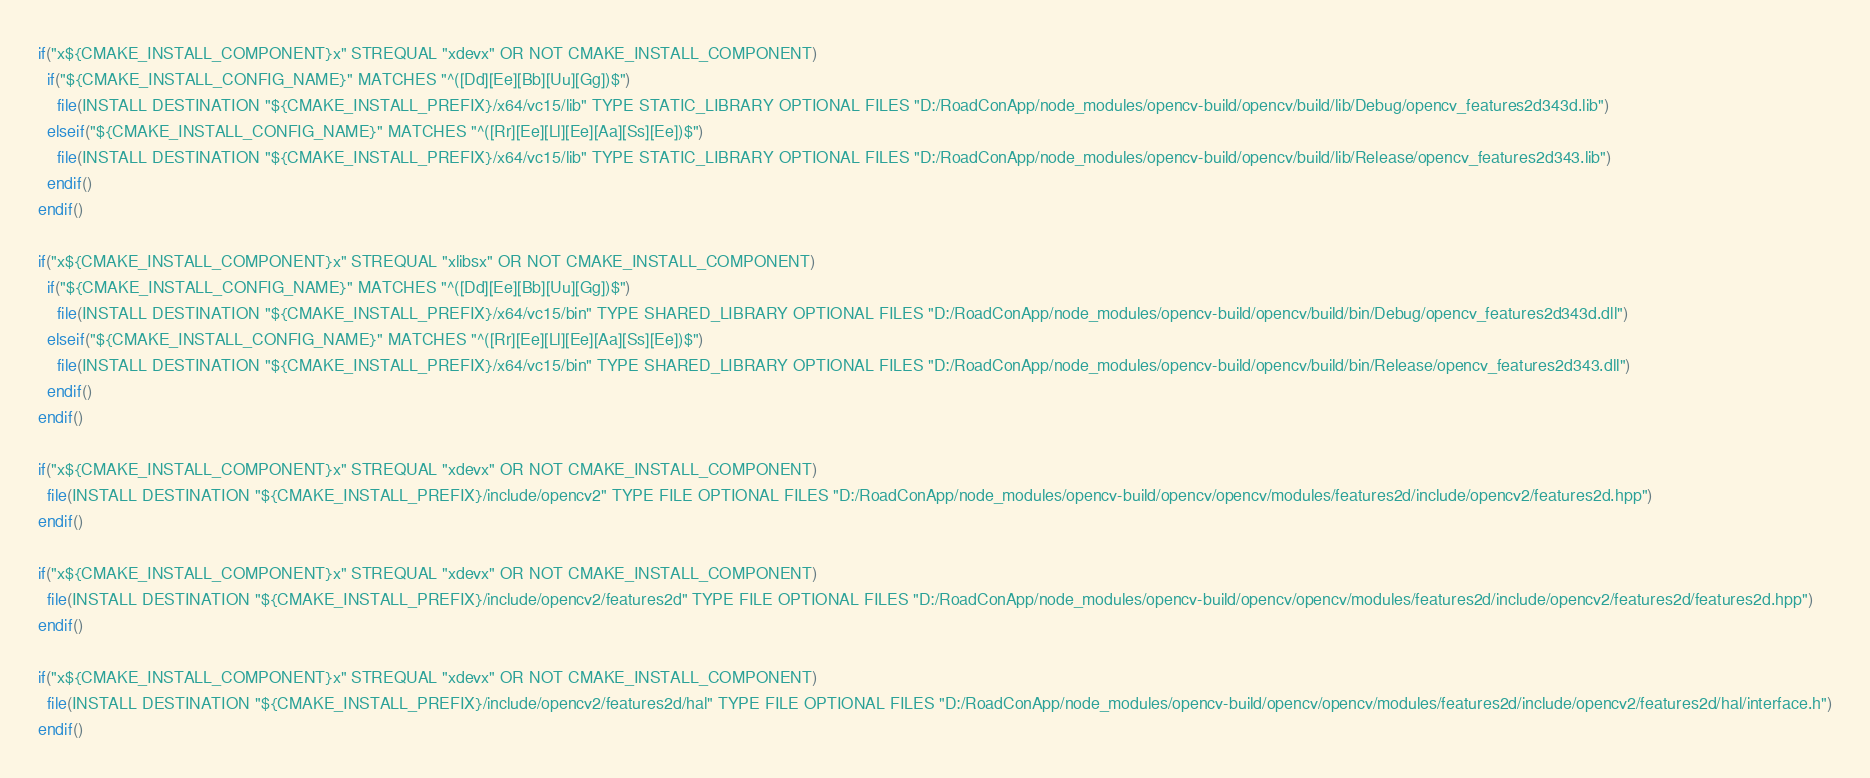Convert code to text. <code><loc_0><loc_0><loc_500><loc_500><_CMake_>if("x${CMAKE_INSTALL_COMPONENT}x" STREQUAL "xdevx" OR NOT CMAKE_INSTALL_COMPONENT)
  if("${CMAKE_INSTALL_CONFIG_NAME}" MATCHES "^([Dd][Ee][Bb][Uu][Gg])$")
    file(INSTALL DESTINATION "${CMAKE_INSTALL_PREFIX}/x64/vc15/lib" TYPE STATIC_LIBRARY OPTIONAL FILES "D:/RoadConApp/node_modules/opencv-build/opencv/build/lib/Debug/opencv_features2d343d.lib")
  elseif("${CMAKE_INSTALL_CONFIG_NAME}" MATCHES "^([Rr][Ee][Ll][Ee][Aa][Ss][Ee])$")
    file(INSTALL DESTINATION "${CMAKE_INSTALL_PREFIX}/x64/vc15/lib" TYPE STATIC_LIBRARY OPTIONAL FILES "D:/RoadConApp/node_modules/opencv-build/opencv/build/lib/Release/opencv_features2d343.lib")
  endif()
endif()

if("x${CMAKE_INSTALL_COMPONENT}x" STREQUAL "xlibsx" OR NOT CMAKE_INSTALL_COMPONENT)
  if("${CMAKE_INSTALL_CONFIG_NAME}" MATCHES "^([Dd][Ee][Bb][Uu][Gg])$")
    file(INSTALL DESTINATION "${CMAKE_INSTALL_PREFIX}/x64/vc15/bin" TYPE SHARED_LIBRARY OPTIONAL FILES "D:/RoadConApp/node_modules/opencv-build/opencv/build/bin/Debug/opencv_features2d343d.dll")
  elseif("${CMAKE_INSTALL_CONFIG_NAME}" MATCHES "^([Rr][Ee][Ll][Ee][Aa][Ss][Ee])$")
    file(INSTALL DESTINATION "${CMAKE_INSTALL_PREFIX}/x64/vc15/bin" TYPE SHARED_LIBRARY OPTIONAL FILES "D:/RoadConApp/node_modules/opencv-build/opencv/build/bin/Release/opencv_features2d343.dll")
  endif()
endif()

if("x${CMAKE_INSTALL_COMPONENT}x" STREQUAL "xdevx" OR NOT CMAKE_INSTALL_COMPONENT)
  file(INSTALL DESTINATION "${CMAKE_INSTALL_PREFIX}/include/opencv2" TYPE FILE OPTIONAL FILES "D:/RoadConApp/node_modules/opencv-build/opencv/opencv/modules/features2d/include/opencv2/features2d.hpp")
endif()

if("x${CMAKE_INSTALL_COMPONENT}x" STREQUAL "xdevx" OR NOT CMAKE_INSTALL_COMPONENT)
  file(INSTALL DESTINATION "${CMAKE_INSTALL_PREFIX}/include/opencv2/features2d" TYPE FILE OPTIONAL FILES "D:/RoadConApp/node_modules/opencv-build/opencv/opencv/modules/features2d/include/opencv2/features2d/features2d.hpp")
endif()

if("x${CMAKE_INSTALL_COMPONENT}x" STREQUAL "xdevx" OR NOT CMAKE_INSTALL_COMPONENT)
  file(INSTALL DESTINATION "${CMAKE_INSTALL_PREFIX}/include/opencv2/features2d/hal" TYPE FILE OPTIONAL FILES "D:/RoadConApp/node_modules/opencv-build/opencv/opencv/modules/features2d/include/opencv2/features2d/hal/interface.h")
endif()

</code> 